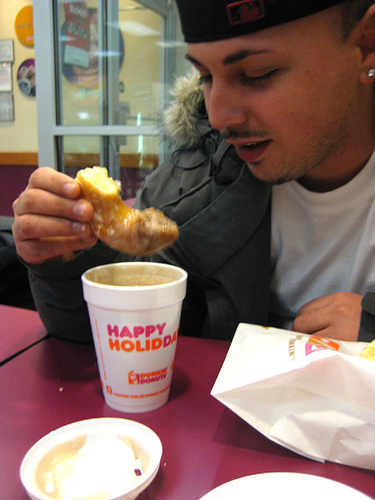<image>What month was this picture taken in? I am not sure what month the picture was taken in. It could be either December or January. What month was this picture taken in? It is not clear which month this picture was taken in. It could be either December or January. 